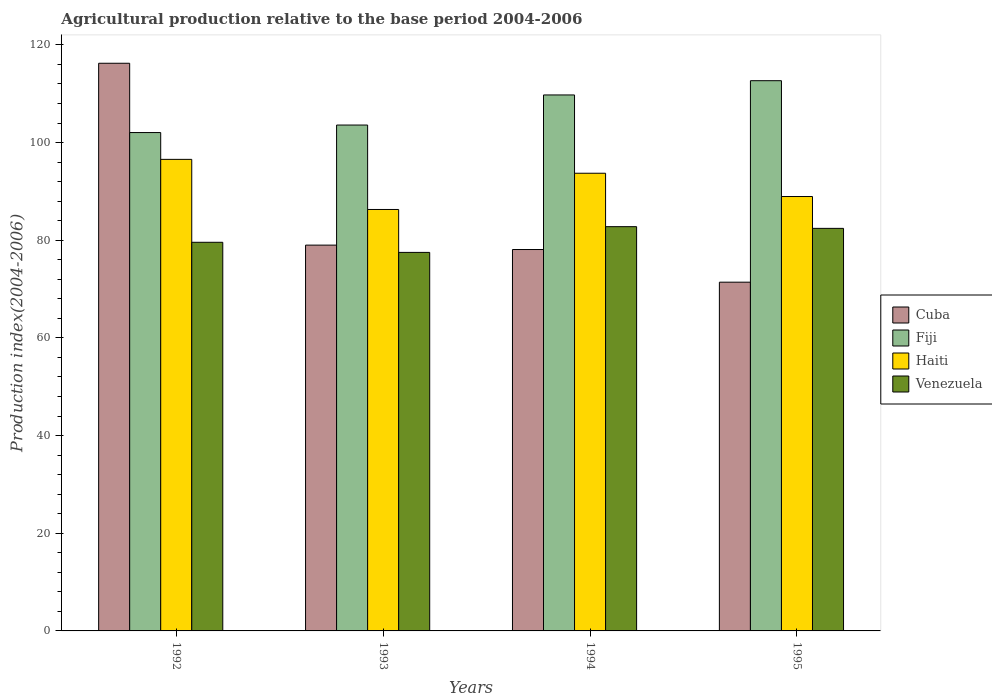Are the number of bars per tick equal to the number of legend labels?
Provide a succinct answer. Yes. Are the number of bars on each tick of the X-axis equal?
Ensure brevity in your answer.  Yes. How many bars are there on the 4th tick from the left?
Your answer should be compact. 4. What is the agricultural production index in Fiji in 1994?
Keep it short and to the point. 109.75. Across all years, what is the maximum agricultural production index in Venezuela?
Your response must be concise. 82.78. Across all years, what is the minimum agricultural production index in Fiji?
Offer a terse response. 102.05. What is the total agricultural production index in Cuba in the graph?
Offer a very short reply. 344.75. What is the difference between the agricultural production index in Haiti in 1992 and that in 1993?
Give a very brief answer. 10.26. What is the difference between the agricultural production index in Cuba in 1994 and the agricultural production index in Fiji in 1995?
Offer a very short reply. -34.57. What is the average agricultural production index in Fiji per year?
Your response must be concise. 107.02. In the year 1994, what is the difference between the agricultural production index in Cuba and agricultural production index in Venezuela?
Keep it short and to the point. -4.68. In how many years, is the agricultural production index in Fiji greater than 44?
Make the answer very short. 4. What is the ratio of the agricultural production index in Fiji in 1994 to that in 1995?
Provide a short and direct response. 0.97. Is the agricultural production index in Cuba in 1992 less than that in 1994?
Give a very brief answer. No. What is the difference between the highest and the second highest agricultural production index in Haiti?
Your answer should be compact. 2.84. What is the difference between the highest and the lowest agricultural production index in Haiti?
Provide a succinct answer. 10.26. In how many years, is the agricultural production index in Haiti greater than the average agricultural production index in Haiti taken over all years?
Ensure brevity in your answer.  2. Is the sum of the agricultural production index in Venezuela in 1993 and 1995 greater than the maximum agricultural production index in Cuba across all years?
Ensure brevity in your answer.  Yes. Is it the case that in every year, the sum of the agricultural production index in Fiji and agricultural production index in Cuba is greater than the sum of agricultural production index in Venezuela and agricultural production index in Haiti?
Your response must be concise. Yes. What does the 2nd bar from the left in 1993 represents?
Ensure brevity in your answer.  Fiji. What does the 1st bar from the right in 1995 represents?
Your answer should be compact. Venezuela. How many bars are there?
Your answer should be compact. 16. Are the values on the major ticks of Y-axis written in scientific E-notation?
Offer a very short reply. No. Does the graph contain any zero values?
Your response must be concise. No. Does the graph contain grids?
Ensure brevity in your answer.  No. Where does the legend appear in the graph?
Give a very brief answer. Center right. What is the title of the graph?
Make the answer very short. Agricultural production relative to the base period 2004-2006. Does "Chile" appear as one of the legend labels in the graph?
Your response must be concise. No. What is the label or title of the X-axis?
Your response must be concise. Years. What is the label or title of the Y-axis?
Give a very brief answer. Production index(2004-2006). What is the Production index(2004-2006) of Cuba in 1992?
Provide a short and direct response. 116.24. What is the Production index(2004-2006) of Fiji in 1992?
Provide a short and direct response. 102.05. What is the Production index(2004-2006) of Haiti in 1992?
Ensure brevity in your answer.  96.56. What is the Production index(2004-2006) in Venezuela in 1992?
Your answer should be very brief. 79.58. What is the Production index(2004-2006) of Cuba in 1993?
Provide a succinct answer. 79. What is the Production index(2004-2006) of Fiji in 1993?
Give a very brief answer. 103.59. What is the Production index(2004-2006) in Haiti in 1993?
Keep it short and to the point. 86.3. What is the Production index(2004-2006) in Venezuela in 1993?
Offer a very short reply. 77.51. What is the Production index(2004-2006) of Cuba in 1994?
Offer a very short reply. 78.1. What is the Production index(2004-2006) of Fiji in 1994?
Offer a terse response. 109.75. What is the Production index(2004-2006) of Haiti in 1994?
Give a very brief answer. 93.72. What is the Production index(2004-2006) of Venezuela in 1994?
Provide a succinct answer. 82.78. What is the Production index(2004-2006) of Cuba in 1995?
Provide a short and direct response. 71.41. What is the Production index(2004-2006) in Fiji in 1995?
Your answer should be compact. 112.67. What is the Production index(2004-2006) in Haiti in 1995?
Ensure brevity in your answer.  88.95. What is the Production index(2004-2006) of Venezuela in 1995?
Provide a succinct answer. 82.43. Across all years, what is the maximum Production index(2004-2006) in Cuba?
Offer a terse response. 116.24. Across all years, what is the maximum Production index(2004-2006) of Fiji?
Provide a short and direct response. 112.67. Across all years, what is the maximum Production index(2004-2006) in Haiti?
Provide a succinct answer. 96.56. Across all years, what is the maximum Production index(2004-2006) of Venezuela?
Make the answer very short. 82.78. Across all years, what is the minimum Production index(2004-2006) of Cuba?
Offer a terse response. 71.41. Across all years, what is the minimum Production index(2004-2006) in Fiji?
Offer a very short reply. 102.05. Across all years, what is the minimum Production index(2004-2006) in Haiti?
Offer a terse response. 86.3. Across all years, what is the minimum Production index(2004-2006) of Venezuela?
Your answer should be compact. 77.51. What is the total Production index(2004-2006) in Cuba in the graph?
Your response must be concise. 344.75. What is the total Production index(2004-2006) of Fiji in the graph?
Give a very brief answer. 428.06. What is the total Production index(2004-2006) of Haiti in the graph?
Your answer should be compact. 365.53. What is the total Production index(2004-2006) in Venezuela in the graph?
Your answer should be compact. 322.3. What is the difference between the Production index(2004-2006) of Cuba in 1992 and that in 1993?
Ensure brevity in your answer.  37.24. What is the difference between the Production index(2004-2006) of Fiji in 1992 and that in 1993?
Make the answer very short. -1.54. What is the difference between the Production index(2004-2006) of Haiti in 1992 and that in 1993?
Offer a terse response. 10.26. What is the difference between the Production index(2004-2006) of Venezuela in 1992 and that in 1993?
Make the answer very short. 2.07. What is the difference between the Production index(2004-2006) in Cuba in 1992 and that in 1994?
Give a very brief answer. 38.14. What is the difference between the Production index(2004-2006) in Haiti in 1992 and that in 1994?
Provide a short and direct response. 2.84. What is the difference between the Production index(2004-2006) in Venezuela in 1992 and that in 1994?
Give a very brief answer. -3.2. What is the difference between the Production index(2004-2006) of Cuba in 1992 and that in 1995?
Your answer should be very brief. 44.83. What is the difference between the Production index(2004-2006) in Fiji in 1992 and that in 1995?
Keep it short and to the point. -10.62. What is the difference between the Production index(2004-2006) in Haiti in 1992 and that in 1995?
Ensure brevity in your answer.  7.61. What is the difference between the Production index(2004-2006) of Venezuela in 1992 and that in 1995?
Make the answer very short. -2.85. What is the difference between the Production index(2004-2006) in Fiji in 1993 and that in 1994?
Offer a terse response. -6.16. What is the difference between the Production index(2004-2006) in Haiti in 1993 and that in 1994?
Give a very brief answer. -7.42. What is the difference between the Production index(2004-2006) in Venezuela in 1993 and that in 1994?
Offer a terse response. -5.27. What is the difference between the Production index(2004-2006) of Cuba in 1993 and that in 1995?
Give a very brief answer. 7.59. What is the difference between the Production index(2004-2006) of Fiji in 1993 and that in 1995?
Make the answer very short. -9.08. What is the difference between the Production index(2004-2006) in Haiti in 1993 and that in 1995?
Your response must be concise. -2.65. What is the difference between the Production index(2004-2006) in Venezuela in 1993 and that in 1995?
Ensure brevity in your answer.  -4.92. What is the difference between the Production index(2004-2006) of Cuba in 1994 and that in 1995?
Your answer should be very brief. 6.69. What is the difference between the Production index(2004-2006) of Fiji in 1994 and that in 1995?
Your answer should be very brief. -2.92. What is the difference between the Production index(2004-2006) in Haiti in 1994 and that in 1995?
Offer a very short reply. 4.77. What is the difference between the Production index(2004-2006) in Venezuela in 1994 and that in 1995?
Offer a very short reply. 0.35. What is the difference between the Production index(2004-2006) of Cuba in 1992 and the Production index(2004-2006) of Fiji in 1993?
Make the answer very short. 12.65. What is the difference between the Production index(2004-2006) in Cuba in 1992 and the Production index(2004-2006) in Haiti in 1993?
Your answer should be compact. 29.94. What is the difference between the Production index(2004-2006) of Cuba in 1992 and the Production index(2004-2006) of Venezuela in 1993?
Provide a short and direct response. 38.73. What is the difference between the Production index(2004-2006) of Fiji in 1992 and the Production index(2004-2006) of Haiti in 1993?
Offer a very short reply. 15.75. What is the difference between the Production index(2004-2006) in Fiji in 1992 and the Production index(2004-2006) in Venezuela in 1993?
Ensure brevity in your answer.  24.54. What is the difference between the Production index(2004-2006) in Haiti in 1992 and the Production index(2004-2006) in Venezuela in 1993?
Make the answer very short. 19.05. What is the difference between the Production index(2004-2006) in Cuba in 1992 and the Production index(2004-2006) in Fiji in 1994?
Offer a very short reply. 6.49. What is the difference between the Production index(2004-2006) in Cuba in 1992 and the Production index(2004-2006) in Haiti in 1994?
Your answer should be very brief. 22.52. What is the difference between the Production index(2004-2006) of Cuba in 1992 and the Production index(2004-2006) of Venezuela in 1994?
Your answer should be very brief. 33.46. What is the difference between the Production index(2004-2006) of Fiji in 1992 and the Production index(2004-2006) of Haiti in 1994?
Make the answer very short. 8.33. What is the difference between the Production index(2004-2006) in Fiji in 1992 and the Production index(2004-2006) in Venezuela in 1994?
Make the answer very short. 19.27. What is the difference between the Production index(2004-2006) of Haiti in 1992 and the Production index(2004-2006) of Venezuela in 1994?
Your answer should be compact. 13.78. What is the difference between the Production index(2004-2006) of Cuba in 1992 and the Production index(2004-2006) of Fiji in 1995?
Your answer should be compact. 3.57. What is the difference between the Production index(2004-2006) of Cuba in 1992 and the Production index(2004-2006) of Haiti in 1995?
Offer a very short reply. 27.29. What is the difference between the Production index(2004-2006) of Cuba in 1992 and the Production index(2004-2006) of Venezuela in 1995?
Provide a succinct answer. 33.81. What is the difference between the Production index(2004-2006) in Fiji in 1992 and the Production index(2004-2006) in Venezuela in 1995?
Give a very brief answer. 19.62. What is the difference between the Production index(2004-2006) of Haiti in 1992 and the Production index(2004-2006) of Venezuela in 1995?
Make the answer very short. 14.13. What is the difference between the Production index(2004-2006) in Cuba in 1993 and the Production index(2004-2006) in Fiji in 1994?
Keep it short and to the point. -30.75. What is the difference between the Production index(2004-2006) in Cuba in 1993 and the Production index(2004-2006) in Haiti in 1994?
Provide a succinct answer. -14.72. What is the difference between the Production index(2004-2006) in Cuba in 1993 and the Production index(2004-2006) in Venezuela in 1994?
Give a very brief answer. -3.78. What is the difference between the Production index(2004-2006) in Fiji in 1993 and the Production index(2004-2006) in Haiti in 1994?
Make the answer very short. 9.87. What is the difference between the Production index(2004-2006) of Fiji in 1993 and the Production index(2004-2006) of Venezuela in 1994?
Your answer should be very brief. 20.81. What is the difference between the Production index(2004-2006) in Haiti in 1993 and the Production index(2004-2006) in Venezuela in 1994?
Keep it short and to the point. 3.52. What is the difference between the Production index(2004-2006) in Cuba in 1993 and the Production index(2004-2006) in Fiji in 1995?
Your answer should be compact. -33.67. What is the difference between the Production index(2004-2006) in Cuba in 1993 and the Production index(2004-2006) in Haiti in 1995?
Provide a succinct answer. -9.95. What is the difference between the Production index(2004-2006) in Cuba in 1993 and the Production index(2004-2006) in Venezuela in 1995?
Provide a succinct answer. -3.43. What is the difference between the Production index(2004-2006) of Fiji in 1993 and the Production index(2004-2006) of Haiti in 1995?
Keep it short and to the point. 14.64. What is the difference between the Production index(2004-2006) in Fiji in 1993 and the Production index(2004-2006) in Venezuela in 1995?
Provide a short and direct response. 21.16. What is the difference between the Production index(2004-2006) of Haiti in 1993 and the Production index(2004-2006) of Venezuela in 1995?
Offer a very short reply. 3.87. What is the difference between the Production index(2004-2006) in Cuba in 1994 and the Production index(2004-2006) in Fiji in 1995?
Provide a succinct answer. -34.57. What is the difference between the Production index(2004-2006) in Cuba in 1994 and the Production index(2004-2006) in Haiti in 1995?
Your answer should be very brief. -10.85. What is the difference between the Production index(2004-2006) in Cuba in 1994 and the Production index(2004-2006) in Venezuela in 1995?
Give a very brief answer. -4.33. What is the difference between the Production index(2004-2006) of Fiji in 1994 and the Production index(2004-2006) of Haiti in 1995?
Ensure brevity in your answer.  20.8. What is the difference between the Production index(2004-2006) of Fiji in 1994 and the Production index(2004-2006) of Venezuela in 1995?
Ensure brevity in your answer.  27.32. What is the difference between the Production index(2004-2006) in Haiti in 1994 and the Production index(2004-2006) in Venezuela in 1995?
Offer a terse response. 11.29. What is the average Production index(2004-2006) of Cuba per year?
Ensure brevity in your answer.  86.19. What is the average Production index(2004-2006) of Fiji per year?
Offer a very short reply. 107.02. What is the average Production index(2004-2006) in Haiti per year?
Your response must be concise. 91.38. What is the average Production index(2004-2006) of Venezuela per year?
Your answer should be compact. 80.58. In the year 1992, what is the difference between the Production index(2004-2006) in Cuba and Production index(2004-2006) in Fiji?
Offer a terse response. 14.19. In the year 1992, what is the difference between the Production index(2004-2006) of Cuba and Production index(2004-2006) of Haiti?
Offer a terse response. 19.68. In the year 1992, what is the difference between the Production index(2004-2006) in Cuba and Production index(2004-2006) in Venezuela?
Ensure brevity in your answer.  36.66. In the year 1992, what is the difference between the Production index(2004-2006) of Fiji and Production index(2004-2006) of Haiti?
Provide a succinct answer. 5.49. In the year 1992, what is the difference between the Production index(2004-2006) of Fiji and Production index(2004-2006) of Venezuela?
Ensure brevity in your answer.  22.47. In the year 1992, what is the difference between the Production index(2004-2006) in Haiti and Production index(2004-2006) in Venezuela?
Ensure brevity in your answer.  16.98. In the year 1993, what is the difference between the Production index(2004-2006) in Cuba and Production index(2004-2006) in Fiji?
Give a very brief answer. -24.59. In the year 1993, what is the difference between the Production index(2004-2006) of Cuba and Production index(2004-2006) of Haiti?
Your answer should be compact. -7.3. In the year 1993, what is the difference between the Production index(2004-2006) in Cuba and Production index(2004-2006) in Venezuela?
Give a very brief answer. 1.49. In the year 1993, what is the difference between the Production index(2004-2006) in Fiji and Production index(2004-2006) in Haiti?
Provide a short and direct response. 17.29. In the year 1993, what is the difference between the Production index(2004-2006) of Fiji and Production index(2004-2006) of Venezuela?
Make the answer very short. 26.08. In the year 1993, what is the difference between the Production index(2004-2006) of Haiti and Production index(2004-2006) of Venezuela?
Provide a succinct answer. 8.79. In the year 1994, what is the difference between the Production index(2004-2006) in Cuba and Production index(2004-2006) in Fiji?
Offer a terse response. -31.65. In the year 1994, what is the difference between the Production index(2004-2006) of Cuba and Production index(2004-2006) of Haiti?
Your answer should be very brief. -15.62. In the year 1994, what is the difference between the Production index(2004-2006) of Cuba and Production index(2004-2006) of Venezuela?
Make the answer very short. -4.68. In the year 1994, what is the difference between the Production index(2004-2006) of Fiji and Production index(2004-2006) of Haiti?
Provide a succinct answer. 16.03. In the year 1994, what is the difference between the Production index(2004-2006) of Fiji and Production index(2004-2006) of Venezuela?
Your response must be concise. 26.97. In the year 1994, what is the difference between the Production index(2004-2006) in Haiti and Production index(2004-2006) in Venezuela?
Your answer should be very brief. 10.94. In the year 1995, what is the difference between the Production index(2004-2006) of Cuba and Production index(2004-2006) of Fiji?
Provide a succinct answer. -41.26. In the year 1995, what is the difference between the Production index(2004-2006) of Cuba and Production index(2004-2006) of Haiti?
Give a very brief answer. -17.54. In the year 1995, what is the difference between the Production index(2004-2006) in Cuba and Production index(2004-2006) in Venezuela?
Give a very brief answer. -11.02. In the year 1995, what is the difference between the Production index(2004-2006) in Fiji and Production index(2004-2006) in Haiti?
Your response must be concise. 23.72. In the year 1995, what is the difference between the Production index(2004-2006) in Fiji and Production index(2004-2006) in Venezuela?
Ensure brevity in your answer.  30.24. In the year 1995, what is the difference between the Production index(2004-2006) of Haiti and Production index(2004-2006) of Venezuela?
Offer a very short reply. 6.52. What is the ratio of the Production index(2004-2006) of Cuba in 1992 to that in 1993?
Your response must be concise. 1.47. What is the ratio of the Production index(2004-2006) in Fiji in 1992 to that in 1993?
Provide a short and direct response. 0.99. What is the ratio of the Production index(2004-2006) of Haiti in 1992 to that in 1993?
Your response must be concise. 1.12. What is the ratio of the Production index(2004-2006) in Venezuela in 1992 to that in 1993?
Your answer should be compact. 1.03. What is the ratio of the Production index(2004-2006) in Cuba in 1992 to that in 1994?
Your response must be concise. 1.49. What is the ratio of the Production index(2004-2006) in Fiji in 1992 to that in 1994?
Your answer should be compact. 0.93. What is the ratio of the Production index(2004-2006) in Haiti in 1992 to that in 1994?
Offer a very short reply. 1.03. What is the ratio of the Production index(2004-2006) of Venezuela in 1992 to that in 1994?
Your answer should be very brief. 0.96. What is the ratio of the Production index(2004-2006) in Cuba in 1992 to that in 1995?
Provide a succinct answer. 1.63. What is the ratio of the Production index(2004-2006) of Fiji in 1992 to that in 1995?
Your answer should be very brief. 0.91. What is the ratio of the Production index(2004-2006) in Haiti in 1992 to that in 1995?
Your answer should be very brief. 1.09. What is the ratio of the Production index(2004-2006) in Venezuela in 1992 to that in 1995?
Your answer should be compact. 0.97. What is the ratio of the Production index(2004-2006) of Cuba in 1993 to that in 1994?
Keep it short and to the point. 1.01. What is the ratio of the Production index(2004-2006) in Fiji in 1993 to that in 1994?
Ensure brevity in your answer.  0.94. What is the ratio of the Production index(2004-2006) of Haiti in 1993 to that in 1994?
Keep it short and to the point. 0.92. What is the ratio of the Production index(2004-2006) of Venezuela in 1993 to that in 1994?
Make the answer very short. 0.94. What is the ratio of the Production index(2004-2006) in Cuba in 1993 to that in 1995?
Provide a succinct answer. 1.11. What is the ratio of the Production index(2004-2006) in Fiji in 1993 to that in 1995?
Give a very brief answer. 0.92. What is the ratio of the Production index(2004-2006) in Haiti in 1993 to that in 1995?
Your response must be concise. 0.97. What is the ratio of the Production index(2004-2006) of Venezuela in 1993 to that in 1995?
Offer a very short reply. 0.94. What is the ratio of the Production index(2004-2006) in Cuba in 1994 to that in 1995?
Your answer should be compact. 1.09. What is the ratio of the Production index(2004-2006) of Fiji in 1994 to that in 1995?
Provide a succinct answer. 0.97. What is the ratio of the Production index(2004-2006) in Haiti in 1994 to that in 1995?
Your answer should be very brief. 1.05. What is the difference between the highest and the second highest Production index(2004-2006) in Cuba?
Ensure brevity in your answer.  37.24. What is the difference between the highest and the second highest Production index(2004-2006) in Fiji?
Make the answer very short. 2.92. What is the difference between the highest and the second highest Production index(2004-2006) in Haiti?
Offer a very short reply. 2.84. What is the difference between the highest and the second highest Production index(2004-2006) in Venezuela?
Keep it short and to the point. 0.35. What is the difference between the highest and the lowest Production index(2004-2006) in Cuba?
Your answer should be compact. 44.83. What is the difference between the highest and the lowest Production index(2004-2006) in Fiji?
Keep it short and to the point. 10.62. What is the difference between the highest and the lowest Production index(2004-2006) in Haiti?
Offer a very short reply. 10.26. What is the difference between the highest and the lowest Production index(2004-2006) of Venezuela?
Provide a succinct answer. 5.27. 